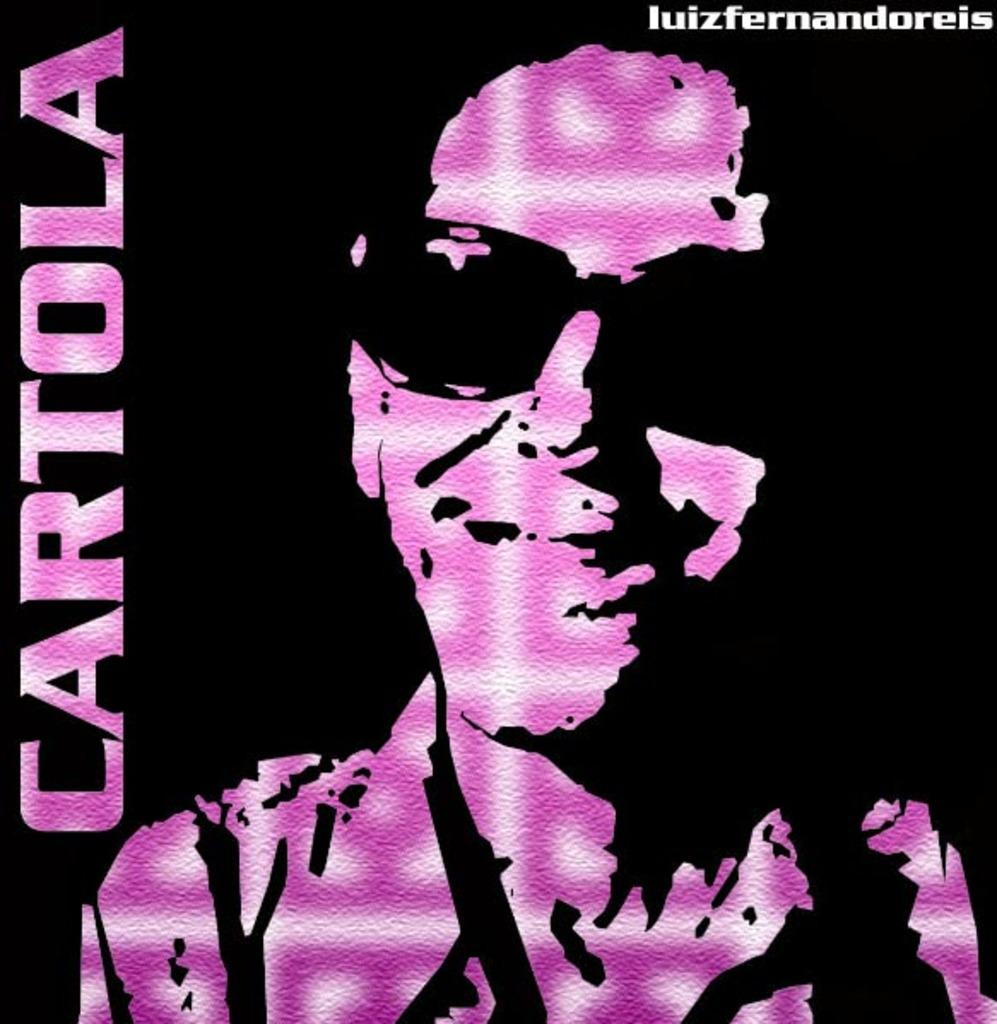What type of visual is shown in the image? The image is a poster. Who or what is depicted in the poster? There is a person in the poster. What is the person wearing in the image? The person is wearing goggles. What else can be found on the poster besides the person? There is text on the poster. What type of glue is being used by the bird in the image? There is no bird present in the image, so it is not possible to determine what type of glue might be used. 